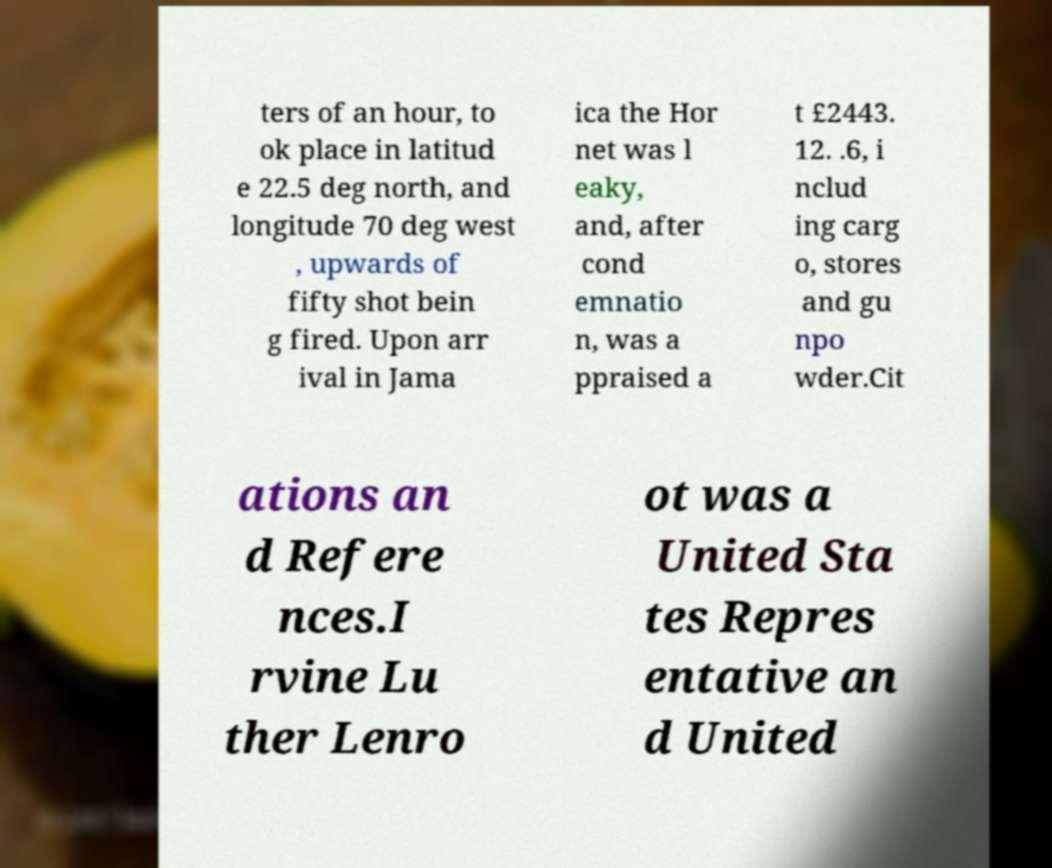What messages or text are displayed in this image? I need them in a readable, typed format. ters of an hour, to ok place in latitud e 22.5 deg north, and longitude 70 deg west , upwards of fifty shot bein g fired. Upon arr ival in Jama ica the Hor net was l eaky, and, after cond emnatio n, was a ppraised a t £2443. 12. .6, i nclud ing carg o, stores and gu npo wder.Cit ations an d Refere nces.I rvine Lu ther Lenro ot was a United Sta tes Repres entative an d United 